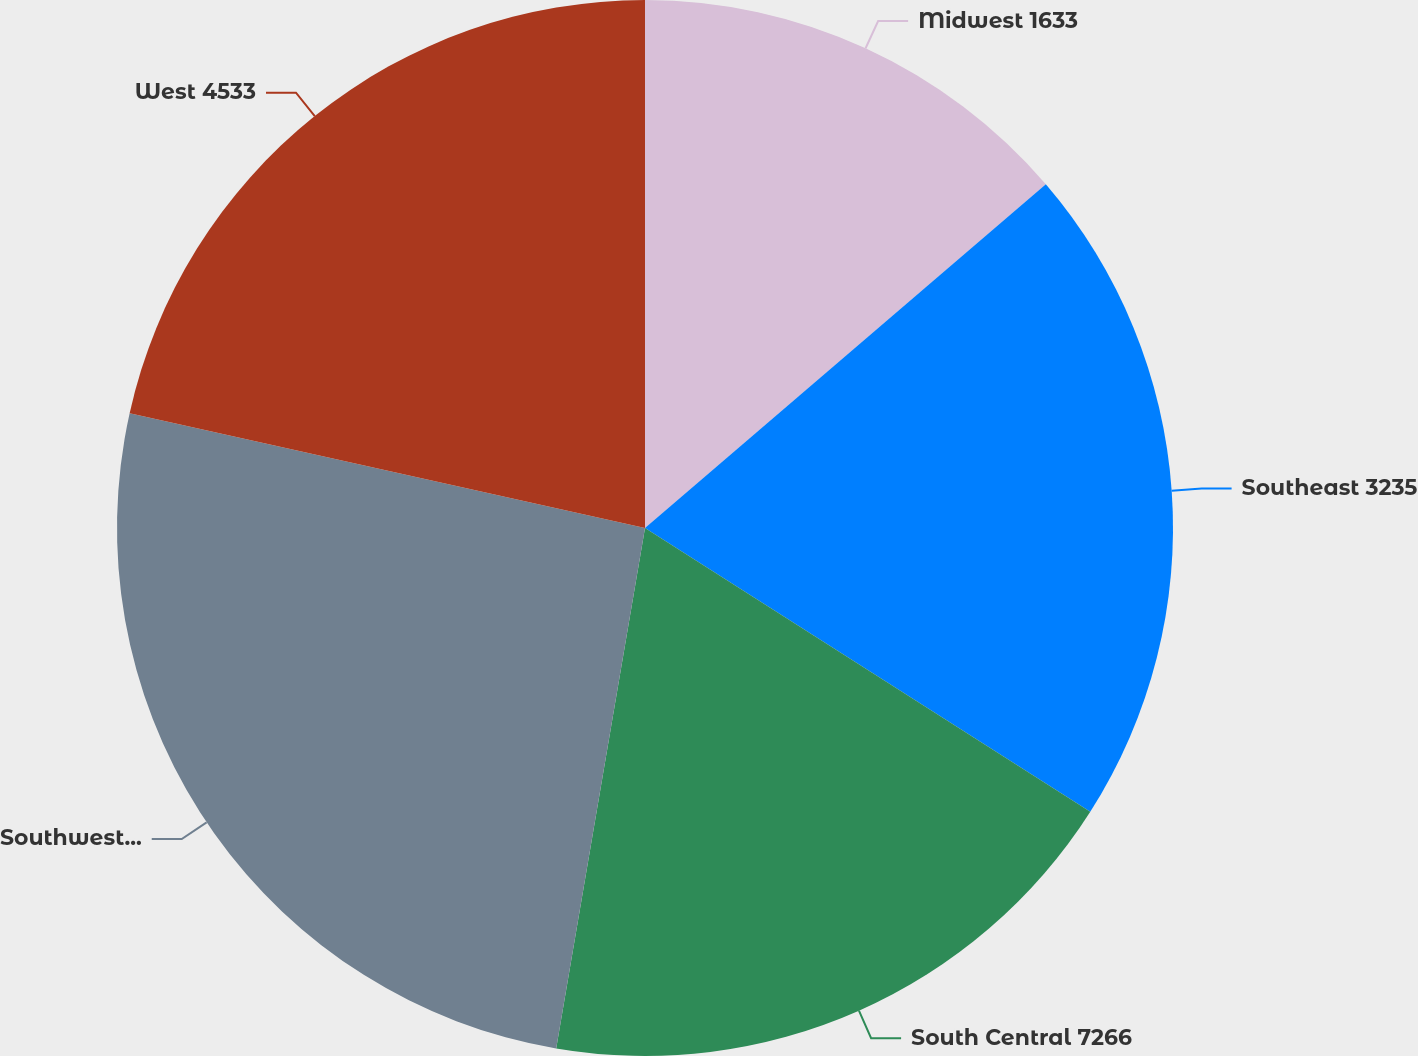Convert chart. <chart><loc_0><loc_0><loc_500><loc_500><pie_chart><fcel>Midwest 1633<fcel>Southeast 3235<fcel>South Central 7266<fcel>Southwest 2982<fcel>West 4533<nl><fcel>13.72%<fcel>20.31%<fcel>18.66%<fcel>25.8%<fcel>21.51%<nl></chart> 